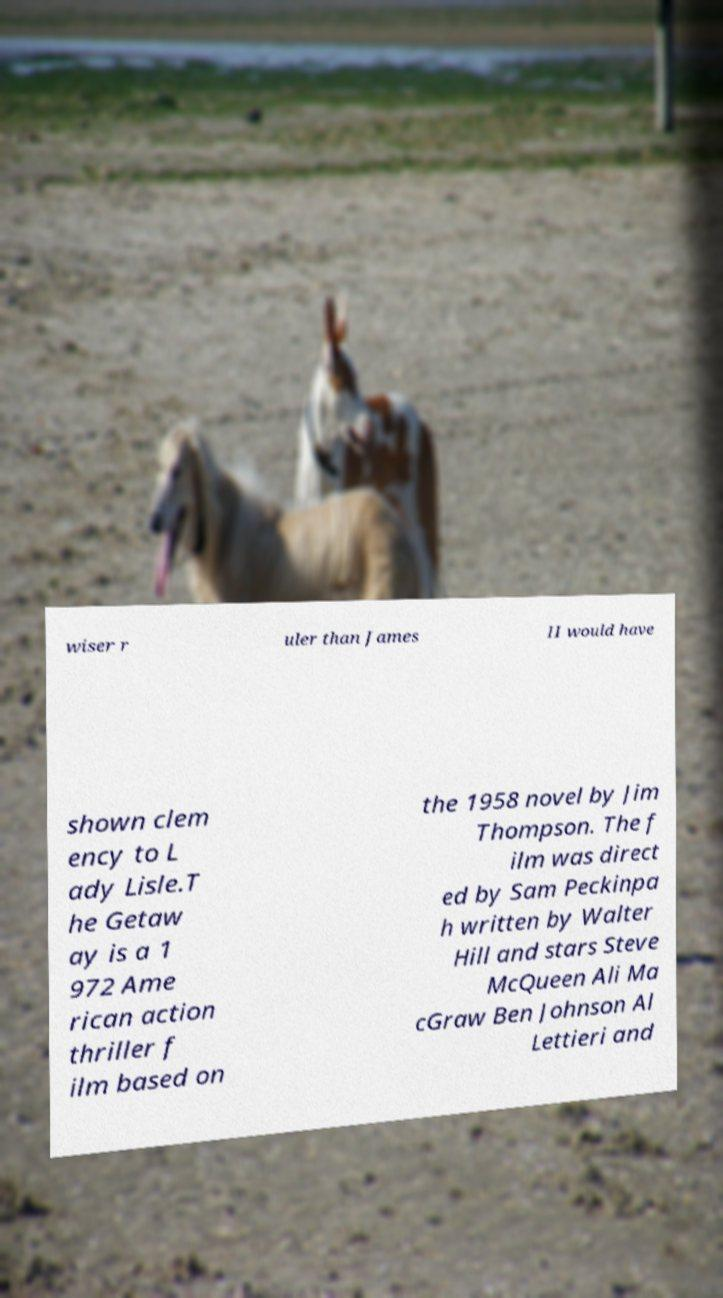There's text embedded in this image that I need extracted. Can you transcribe it verbatim? wiser r uler than James II would have shown clem ency to L ady Lisle.T he Getaw ay is a 1 972 Ame rican action thriller f ilm based on the 1958 novel by Jim Thompson. The f ilm was direct ed by Sam Peckinpa h written by Walter Hill and stars Steve McQueen Ali Ma cGraw Ben Johnson Al Lettieri and 